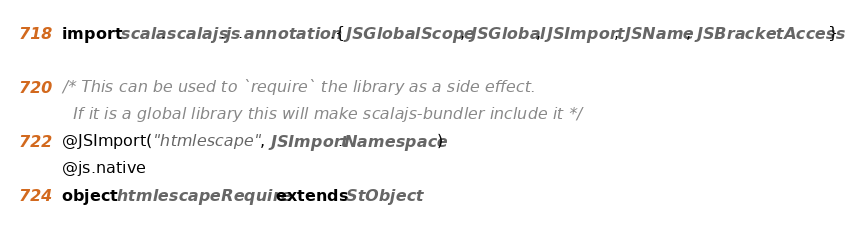Convert code to text. <code><loc_0><loc_0><loc_500><loc_500><_Scala_>import scala.scalajs.js.annotation.{JSGlobalScope, JSGlobal, JSImport, JSName, JSBracketAccess}

/* This can be used to `require` the library as a side effect.
  If it is a global library this will make scalajs-bundler include it */
@JSImport("htmlescape", JSImport.Namespace)
@js.native
object htmlescapeRequire extends StObject
</code> 